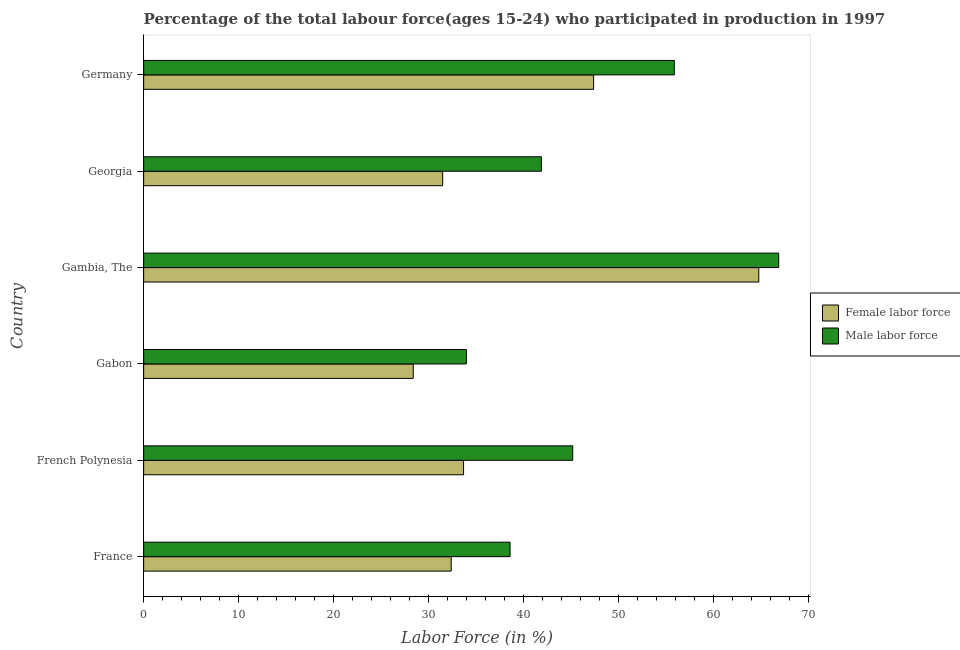How many groups of bars are there?
Keep it short and to the point. 6. Are the number of bars per tick equal to the number of legend labels?
Give a very brief answer. Yes. Are the number of bars on each tick of the Y-axis equal?
Give a very brief answer. Yes. How many bars are there on the 1st tick from the top?
Keep it short and to the point. 2. How many bars are there on the 6th tick from the bottom?
Your answer should be compact. 2. What is the label of the 4th group of bars from the top?
Provide a short and direct response. Gabon. In how many cases, is the number of bars for a given country not equal to the number of legend labels?
Offer a very short reply. 0. What is the percentage of female labor force in Germany?
Keep it short and to the point. 47.4. Across all countries, what is the maximum percentage of male labour force?
Your response must be concise. 66.9. In which country was the percentage of male labour force maximum?
Offer a terse response. Gambia, The. In which country was the percentage of female labor force minimum?
Make the answer very short. Gabon. What is the total percentage of female labor force in the graph?
Offer a terse response. 238.2. What is the difference between the percentage of male labour force in Gabon and that in Gambia, The?
Your answer should be very brief. -32.9. What is the difference between the percentage of female labor force in French Polynesia and the percentage of male labour force in Gabon?
Ensure brevity in your answer.  -0.3. What is the average percentage of female labor force per country?
Keep it short and to the point. 39.7. What is the difference between the percentage of female labor force and percentage of male labour force in Germany?
Provide a short and direct response. -8.5. In how many countries, is the percentage of female labor force greater than 4 %?
Ensure brevity in your answer.  6. What is the ratio of the percentage of female labor force in Gambia, The to that in Georgia?
Provide a short and direct response. 2.06. Is the percentage of female labor force in French Polynesia less than that in Gambia, The?
Your answer should be very brief. Yes. Is the difference between the percentage of male labour force in French Polynesia and Gambia, The greater than the difference between the percentage of female labor force in French Polynesia and Gambia, The?
Give a very brief answer. Yes. What is the difference between the highest and the lowest percentage of female labor force?
Your answer should be very brief. 36.4. In how many countries, is the percentage of male labour force greater than the average percentage of male labour force taken over all countries?
Give a very brief answer. 2. What does the 2nd bar from the top in Gambia, The represents?
Your answer should be very brief. Female labor force. What does the 2nd bar from the bottom in Gambia, The represents?
Offer a very short reply. Male labor force. Are all the bars in the graph horizontal?
Your response must be concise. Yes. How many countries are there in the graph?
Provide a short and direct response. 6. What is the difference between two consecutive major ticks on the X-axis?
Your response must be concise. 10. Are the values on the major ticks of X-axis written in scientific E-notation?
Offer a very short reply. No. Does the graph contain any zero values?
Your answer should be very brief. No. Does the graph contain grids?
Offer a terse response. No. Where does the legend appear in the graph?
Make the answer very short. Center right. How many legend labels are there?
Make the answer very short. 2. What is the title of the graph?
Ensure brevity in your answer.  Percentage of the total labour force(ages 15-24) who participated in production in 1997. What is the Labor Force (in %) of Female labor force in France?
Provide a succinct answer. 32.4. What is the Labor Force (in %) of Male labor force in France?
Your answer should be very brief. 38.6. What is the Labor Force (in %) of Female labor force in French Polynesia?
Give a very brief answer. 33.7. What is the Labor Force (in %) of Male labor force in French Polynesia?
Provide a short and direct response. 45.2. What is the Labor Force (in %) of Female labor force in Gabon?
Provide a succinct answer. 28.4. What is the Labor Force (in %) of Male labor force in Gabon?
Ensure brevity in your answer.  34. What is the Labor Force (in %) of Female labor force in Gambia, The?
Provide a succinct answer. 64.8. What is the Labor Force (in %) of Male labor force in Gambia, The?
Your response must be concise. 66.9. What is the Labor Force (in %) in Female labor force in Georgia?
Ensure brevity in your answer.  31.5. What is the Labor Force (in %) in Male labor force in Georgia?
Your response must be concise. 41.9. What is the Labor Force (in %) in Female labor force in Germany?
Your answer should be very brief. 47.4. What is the Labor Force (in %) in Male labor force in Germany?
Offer a very short reply. 55.9. Across all countries, what is the maximum Labor Force (in %) of Female labor force?
Make the answer very short. 64.8. Across all countries, what is the maximum Labor Force (in %) of Male labor force?
Your answer should be very brief. 66.9. Across all countries, what is the minimum Labor Force (in %) in Female labor force?
Your answer should be very brief. 28.4. Across all countries, what is the minimum Labor Force (in %) of Male labor force?
Offer a terse response. 34. What is the total Labor Force (in %) in Female labor force in the graph?
Ensure brevity in your answer.  238.2. What is the total Labor Force (in %) in Male labor force in the graph?
Offer a very short reply. 282.5. What is the difference between the Labor Force (in %) of Female labor force in France and that in French Polynesia?
Offer a very short reply. -1.3. What is the difference between the Labor Force (in %) of Male labor force in France and that in French Polynesia?
Give a very brief answer. -6.6. What is the difference between the Labor Force (in %) of Male labor force in France and that in Gabon?
Ensure brevity in your answer.  4.6. What is the difference between the Labor Force (in %) of Female labor force in France and that in Gambia, The?
Give a very brief answer. -32.4. What is the difference between the Labor Force (in %) in Male labor force in France and that in Gambia, The?
Offer a terse response. -28.3. What is the difference between the Labor Force (in %) of Female labor force in France and that in Georgia?
Keep it short and to the point. 0.9. What is the difference between the Labor Force (in %) of Male labor force in France and that in Georgia?
Offer a terse response. -3.3. What is the difference between the Labor Force (in %) in Female labor force in France and that in Germany?
Your answer should be very brief. -15. What is the difference between the Labor Force (in %) of Male labor force in France and that in Germany?
Your answer should be compact. -17.3. What is the difference between the Labor Force (in %) of Female labor force in French Polynesia and that in Gabon?
Provide a succinct answer. 5.3. What is the difference between the Labor Force (in %) in Female labor force in French Polynesia and that in Gambia, The?
Your response must be concise. -31.1. What is the difference between the Labor Force (in %) in Male labor force in French Polynesia and that in Gambia, The?
Make the answer very short. -21.7. What is the difference between the Labor Force (in %) of Female labor force in French Polynesia and that in Georgia?
Your response must be concise. 2.2. What is the difference between the Labor Force (in %) in Female labor force in French Polynesia and that in Germany?
Offer a terse response. -13.7. What is the difference between the Labor Force (in %) of Male labor force in French Polynesia and that in Germany?
Keep it short and to the point. -10.7. What is the difference between the Labor Force (in %) of Female labor force in Gabon and that in Gambia, The?
Keep it short and to the point. -36.4. What is the difference between the Labor Force (in %) of Male labor force in Gabon and that in Gambia, The?
Your answer should be very brief. -32.9. What is the difference between the Labor Force (in %) of Female labor force in Gabon and that in Georgia?
Provide a succinct answer. -3.1. What is the difference between the Labor Force (in %) of Male labor force in Gabon and that in Germany?
Offer a terse response. -21.9. What is the difference between the Labor Force (in %) in Female labor force in Gambia, The and that in Georgia?
Your answer should be very brief. 33.3. What is the difference between the Labor Force (in %) in Female labor force in Gambia, The and that in Germany?
Give a very brief answer. 17.4. What is the difference between the Labor Force (in %) of Male labor force in Gambia, The and that in Germany?
Your answer should be very brief. 11. What is the difference between the Labor Force (in %) in Female labor force in Georgia and that in Germany?
Provide a short and direct response. -15.9. What is the difference between the Labor Force (in %) of Male labor force in Georgia and that in Germany?
Ensure brevity in your answer.  -14. What is the difference between the Labor Force (in %) in Female labor force in France and the Labor Force (in %) in Male labor force in French Polynesia?
Your answer should be very brief. -12.8. What is the difference between the Labor Force (in %) of Female labor force in France and the Labor Force (in %) of Male labor force in Gabon?
Make the answer very short. -1.6. What is the difference between the Labor Force (in %) of Female labor force in France and the Labor Force (in %) of Male labor force in Gambia, The?
Your response must be concise. -34.5. What is the difference between the Labor Force (in %) in Female labor force in France and the Labor Force (in %) in Male labor force in Georgia?
Provide a short and direct response. -9.5. What is the difference between the Labor Force (in %) in Female labor force in France and the Labor Force (in %) in Male labor force in Germany?
Make the answer very short. -23.5. What is the difference between the Labor Force (in %) in Female labor force in French Polynesia and the Labor Force (in %) in Male labor force in Gambia, The?
Offer a very short reply. -33.2. What is the difference between the Labor Force (in %) of Female labor force in French Polynesia and the Labor Force (in %) of Male labor force in Georgia?
Offer a terse response. -8.2. What is the difference between the Labor Force (in %) of Female labor force in French Polynesia and the Labor Force (in %) of Male labor force in Germany?
Your answer should be compact. -22.2. What is the difference between the Labor Force (in %) of Female labor force in Gabon and the Labor Force (in %) of Male labor force in Gambia, The?
Offer a very short reply. -38.5. What is the difference between the Labor Force (in %) in Female labor force in Gabon and the Labor Force (in %) in Male labor force in Georgia?
Your answer should be compact. -13.5. What is the difference between the Labor Force (in %) in Female labor force in Gabon and the Labor Force (in %) in Male labor force in Germany?
Your answer should be very brief. -27.5. What is the difference between the Labor Force (in %) in Female labor force in Gambia, The and the Labor Force (in %) in Male labor force in Georgia?
Give a very brief answer. 22.9. What is the difference between the Labor Force (in %) of Female labor force in Georgia and the Labor Force (in %) of Male labor force in Germany?
Ensure brevity in your answer.  -24.4. What is the average Labor Force (in %) in Female labor force per country?
Your answer should be compact. 39.7. What is the average Labor Force (in %) of Male labor force per country?
Provide a succinct answer. 47.08. What is the difference between the Labor Force (in %) in Female labor force and Labor Force (in %) in Male labor force in France?
Give a very brief answer. -6.2. What is the difference between the Labor Force (in %) of Female labor force and Labor Force (in %) of Male labor force in French Polynesia?
Give a very brief answer. -11.5. What is the difference between the Labor Force (in %) in Female labor force and Labor Force (in %) in Male labor force in Gambia, The?
Give a very brief answer. -2.1. What is the ratio of the Labor Force (in %) of Female labor force in France to that in French Polynesia?
Offer a very short reply. 0.96. What is the ratio of the Labor Force (in %) in Male labor force in France to that in French Polynesia?
Provide a short and direct response. 0.85. What is the ratio of the Labor Force (in %) of Female labor force in France to that in Gabon?
Keep it short and to the point. 1.14. What is the ratio of the Labor Force (in %) in Male labor force in France to that in Gabon?
Give a very brief answer. 1.14. What is the ratio of the Labor Force (in %) of Male labor force in France to that in Gambia, The?
Your answer should be very brief. 0.58. What is the ratio of the Labor Force (in %) of Female labor force in France to that in Georgia?
Provide a short and direct response. 1.03. What is the ratio of the Labor Force (in %) of Male labor force in France to that in Georgia?
Your answer should be very brief. 0.92. What is the ratio of the Labor Force (in %) in Female labor force in France to that in Germany?
Ensure brevity in your answer.  0.68. What is the ratio of the Labor Force (in %) of Male labor force in France to that in Germany?
Your response must be concise. 0.69. What is the ratio of the Labor Force (in %) of Female labor force in French Polynesia to that in Gabon?
Make the answer very short. 1.19. What is the ratio of the Labor Force (in %) of Male labor force in French Polynesia to that in Gabon?
Your answer should be very brief. 1.33. What is the ratio of the Labor Force (in %) in Female labor force in French Polynesia to that in Gambia, The?
Make the answer very short. 0.52. What is the ratio of the Labor Force (in %) in Male labor force in French Polynesia to that in Gambia, The?
Your response must be concise. 0.68. What is the ratio of the Labor Force (in %) of Female labor force in French Polynesia to that in Georgia?
Offer a very short reply. 1.07. What is the ratio of the Labor Force (in %) in Male labor force in French Polynesia to that in Georgia?
Provide a short and direct response. 1.08. What is the ratio of the Labor Force (in %) of Female labor force in French Polynesia to that in Germany?
Offer a very short reply. 0.71. What is the ratio of the Labor Force (in %) of Male labor force in French Polynesia to that in Germany?
Offer a very short reply. 0.81. What is the ratio of the Labor Force (in %) of Female labor force in Gabon to that in Gambia, The?
Your response must be concise. 0.44. What is the ratio of the Labor Force (in %) in Male labor force in Gabon to that in Gambia, The?
Your answer should be very brief. 0.51. What is the ratio of the Labor Force (in %) of Female labor force in Gabon to that in Georgia?
Provide a short and direct response. 0.9. What is the ratio of the Labor Force (in %) of Male labor force in Gabon to that in Georgia?
Your answer should be very brief. 0.81. What is the ratio of the Labor Force (in %) of Female labor force in Gabon to that in Germany?
Offer a terse response. 0.6. What is the ratio of the Labor Force (in %) in Male labor force in Gabon to that in Germany?
Your response must be concise. 0.61. What is the ratio of the Labor Force (in %) of Female labor force in Gambia, The to that in Georgia?
Your response must be concise. 2.06. What is the ratio of the Labor Force (in %) in Male labor force in Gambia, The to that in Georgia?
Make the answer very short. 1.6. What is the ratio of the Labor Force (in %) of Female labor force in Gambia, The to that in Germany?
Offer a very short reply. 1.37. What is the ratio of the Labor Force (in %) of Male labor force in Gambia, The to that in Germany?
Your answer should be very brief. 1.2. What is the ratio of the Labor Force (in %) of Female labor force in Georgia to that in Germany?
Make the answer very short. 0.66. What is the ratio of the Labor Force (in %) of Male labor force in Georgia to that in Germany?
Ensure brevity in your answer.  0.75. What is the difference between the highest and the second highest Labor Force (in %) of Female labor force?
Provide a succinct answer. 17.4. What is the difference between the highest and the lowest Labor Force (in %) of Female labor force?
Your response must be concise. 36.4. What is the difference between the highest and the lowest Labor Force (in %) of Male labor force?
Make the answer very short. 32.9. 